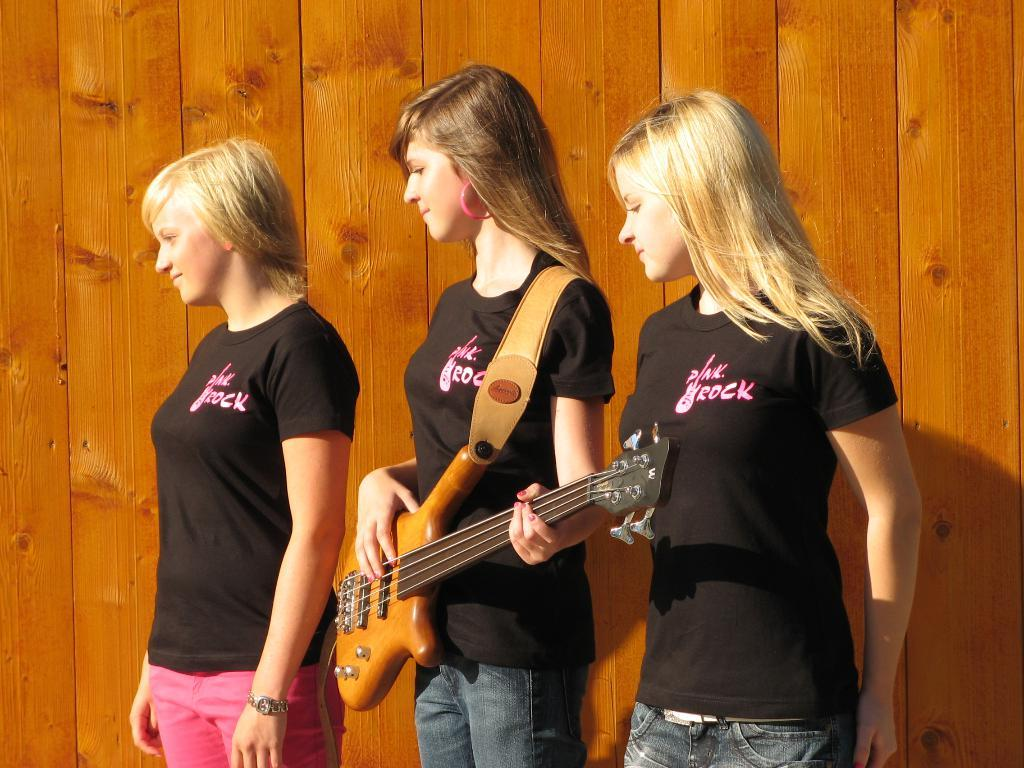How many women are present in the image? There are three women in the image. What are the women wearing? The women are wearing black color t-shirts. Can you describe any specific activity the women are engaged in? One of the women is holding a guitar. What topic are the women discussing in the image? There is no indication of a discussion taking place in the image. Can you describe the type of touch the women are using with each other in the image? There is no physical contact between the women in the image. 